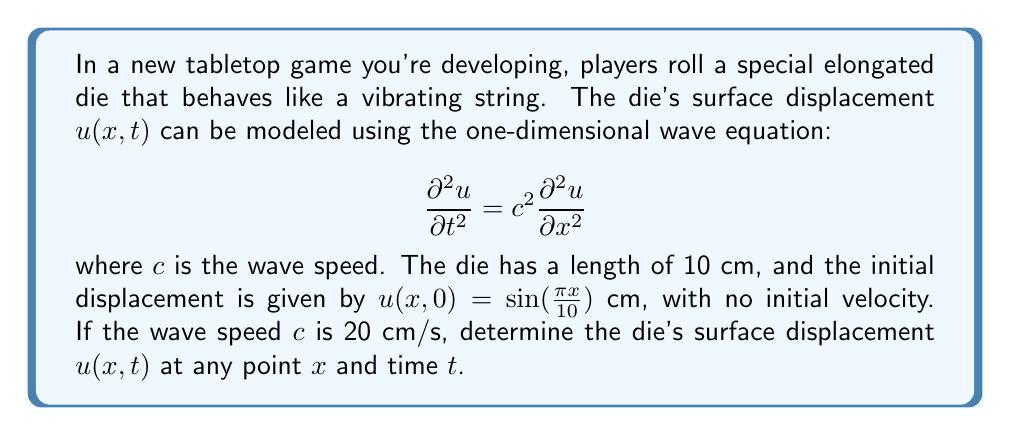Provide a solution to this math problem. To solve this problem, we'll use the method of separation of variables and apply the given initial conditions.

1) Assume a solution of the form $u(x,t) = X(x)T(t)$.

2) Substituting into the wave equation:
   $$X(x)T''(t) = c^2X''(x)T(t)$$
   $$\frac{T''(t)}{c^2T(t)} = \frac{X''(x)}{X(x)} = -k^2$$

3) This gives us two ordinary differential equations:
   $$X''(x) + k^2X(x) = 0$$
   $$T''(t) + c^2k^2T(t) = 0$$

4) The general solutions are:
   $$X(x) = A\sin(kx) + B\cos(kx)$$
   $$T(t) = C\sin(ckt) + D\cos(ckt)$$

5) Apply the boundary conditions: $u(0,t) = u(10,t) = 0$
   This gives $k = \frac{n\pi}{10}$ where $n$ is an integer.

6) The general solution is:
   $$u(x,t) = \sum_{n=1}^{\infty} (A_n\sin(ckt) + B_n\cos(ckt))\sin(\frac{n\pi x}{10})$$

7) Apply the initial conditions:
   $u(x,0) = \sin(\frac{\pi x}{10})$ cm, so $n=1$ and all other terms are zero.
   $\frac{\partial u}{\partial t}(x,0) = 0$, so $A_1 = 0$.

8) Therefore, $B_1 = 1$ and our solution is:
   $$u(x,t) = \cos(\frac{\pi ct}{10})\sin(\frac{\pi x}{10})$$

9) Substituting $c = 20$ cm/s:
   $$u(x,t) = \cos(2\pi t)\sin(\frac{\pi x}{10})$$
Answer: The surface displacement of the die at any point $x$ and time $t$ is given by:
$$u(x,t) = \cos(2\pi t)\sin(\frac{\pi x}{10})$$ cm
where $x$ is in cm and $t$ is in seconds. 